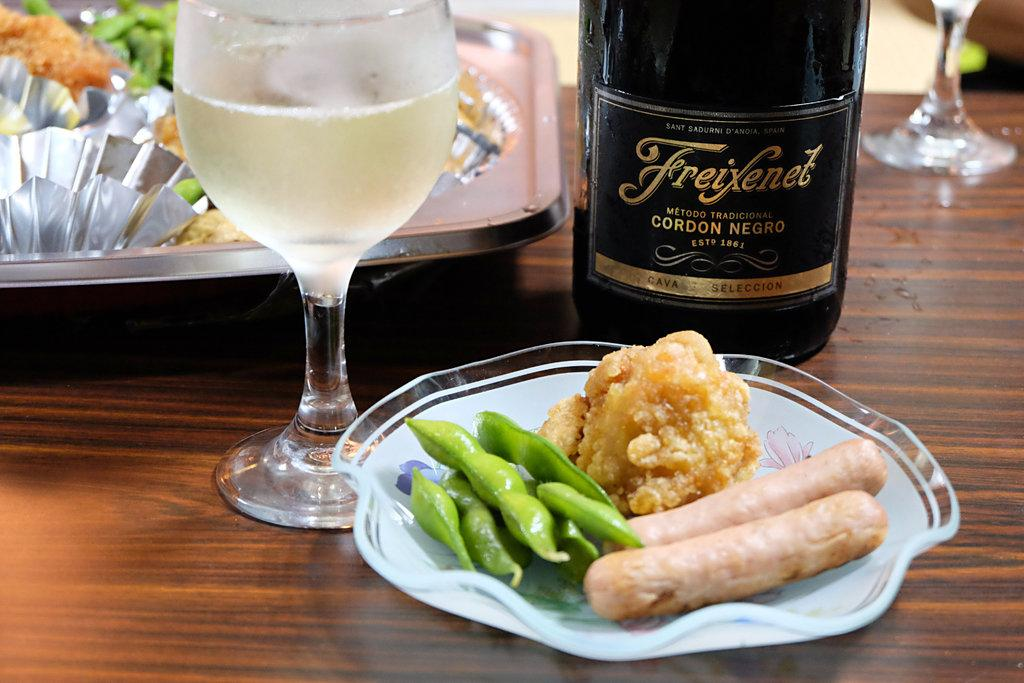<image>
Describe the image concisely. PLate of food by a bottle that says "Gordon Negro". 